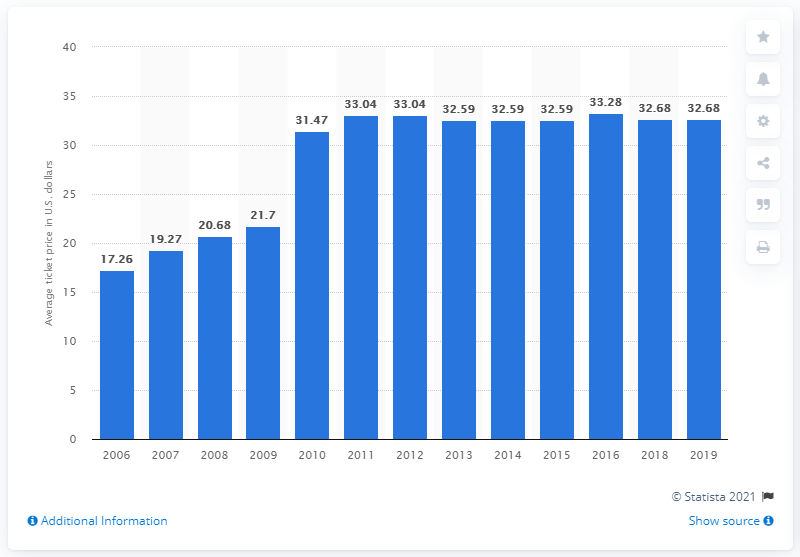Give some essential details in this illustration. In 2019, the average ticket price for Minnesota Twins games was 32.68. 